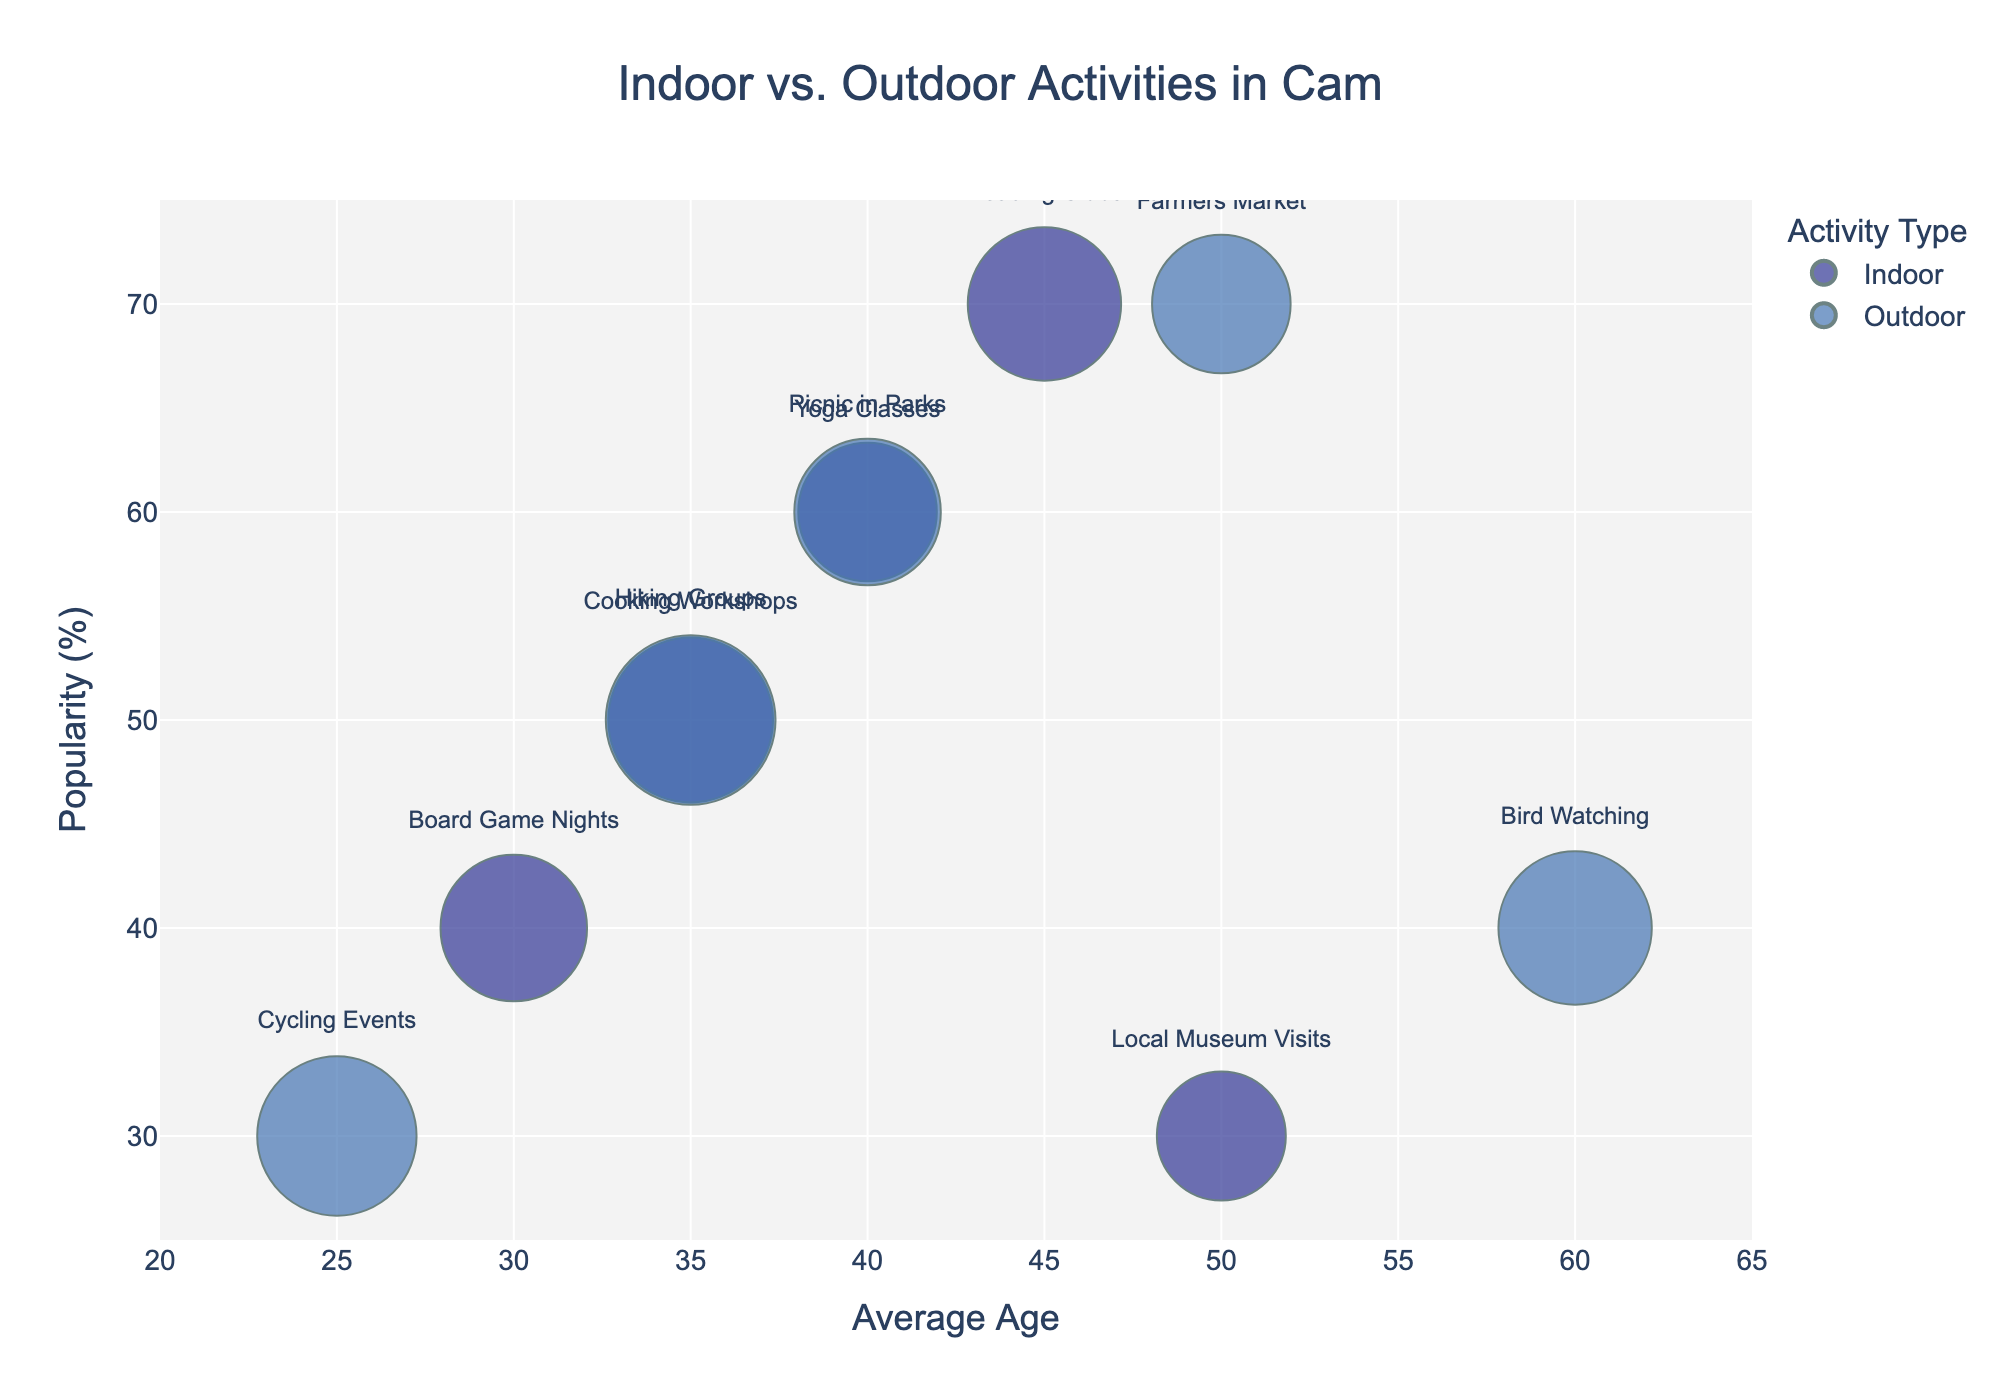What's the title of the chart? The title of the chart is generally located at the top of the plot, typically in a larger font and more prominent in style.
Answer: Indoor vs. Outdoor Activities in Cam How many indoor activities are represented in the chart? In the legend, indoor activities are marked by a specific color. By counting the bubbles in this color, we can determine the number of indoor activities.
Answer: 5 What is the average age for Yoga Classes? Find the bubble labeled "Yoga Classes" and look at the corresponding value on the x-axis, which represents 'Average Age'.
Answer: 40 Which activity type has the highest popularity and what is that activity? Locate the bubble at the highest point on the y-axis (Popularity). Then, identify the color and label of this bubble.
Answer: Indoor, Reading Clubs How does the popularity of Picnic in Parks compare to Board Game Nights? First, locate the bubbles for Picnic in Parks and Board Game Nights. Compare their positions on the y-axis, which indicates their Popularity.
Answer: Picnic in Parks is more popular What is the size of the bubble for the Farmer's Market activity? Locate the bubble for Farmer's Market and observe its size. Bubble size is generally proportional to the value of 'Time Spent', with precise details derived from the figure.
Answer: Moderate but not too large Which activity has participants with the highest average age and what is that age? Identify the bubble farthest to the right on the x-axis, then read its label and corresponding age value.
Answer: Bird Watching, 60 Are there more indoor or outdoor activities represented in the chart? Compare the number of bubbles corresponding to Indoor and Outdoor colors as indicated in the legend.
Answer: Equal, 5 each What’s the average popularity of all indoor activities? List the Popularity values for all indoor activities, sum them, and divide by the number of indoor activities (70, 60, 50, 40, 30). The sum is 250, and mean is 250/5.
Answer: 50 How does the time spent on Hiking Groups compare to Cooking Workshops? Locate the bubbles for Hiking Groups and Cooking Workshops, observe their sizes (proportional to Time Spent), and compare.
Answer: Hiking Groups have slightly larger bubbles (more time) 